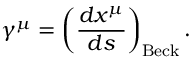Convert formula to latex. <formula><loc_0><loc_0><loc_500><loc_500>\gamma ^ { \mu } = \left ( \frac { d x ^ { \mu } } { d s } \right ) _ { B e c k } .</formula> 